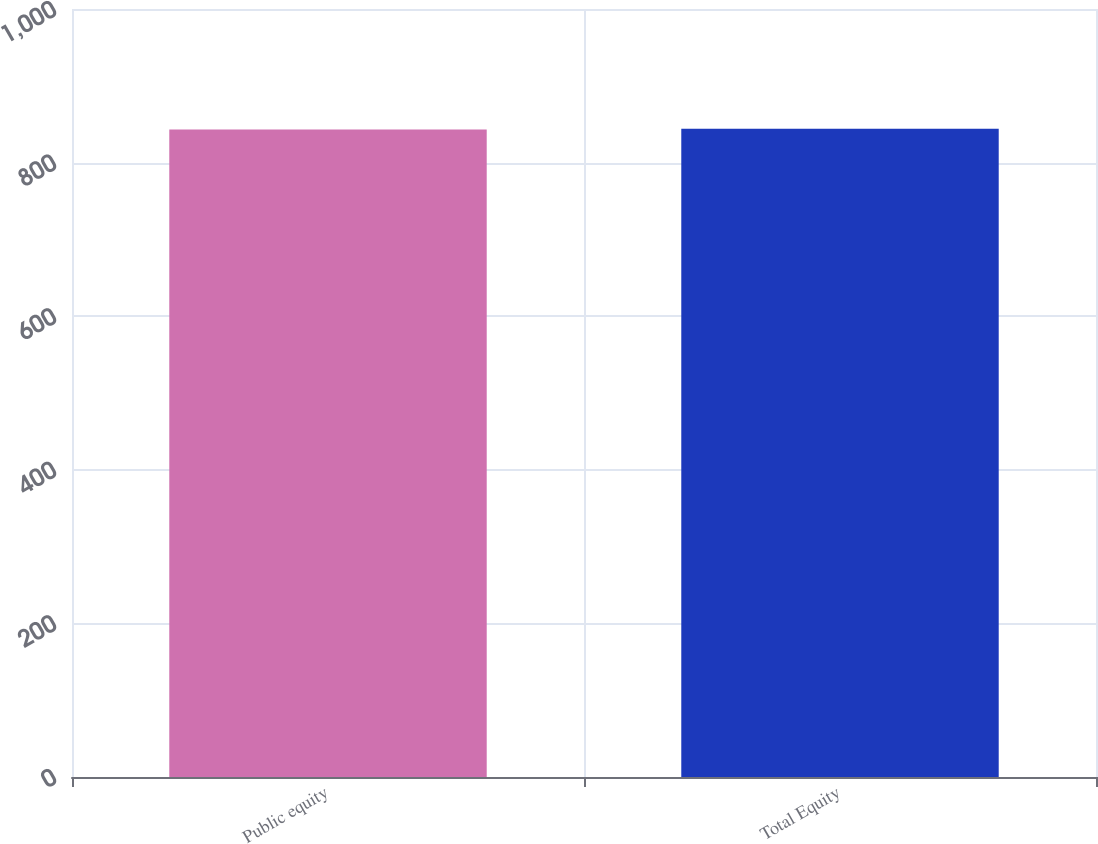Convert chart. <chart><loc_0><loc_0><loc_500><loc_500><bar_chart><fcel>Public equity<fcel>Total Equity<nl><fcel>843<fcel>844<nl></chart> 